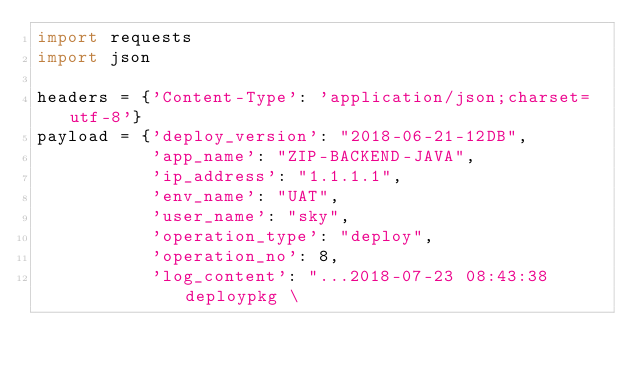<code> <loc_0><loc_0><loc_500><loc_500><_Python_>import requests
import json

headers = {'Content-Type': 'application/json;charset=utf-8'}
payload = {'deploy_version': "2018-06-21-12DB",
           'app_name': "ZIP-BACKEND-JAVA",
           'ip_address': "1.1.1.1",
           'env_name': "UAT",
           'user_name': "sky",
           'operation_type': "deploy",
           'operation_no': 8,
           'log_content': "...2018-07-23 08:43:38 deploypkg \</code> 